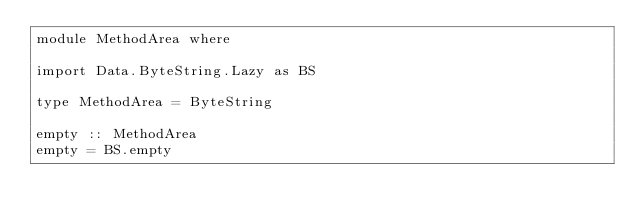<code> <loc_0><loc_0><loc_500><loc_500><_Haskell_>module MethodArea where

import Data.ByteString.Lazy as BS

type MethodArea = ByteString

empty :: MethodArea
empty = BS.empty</code> 